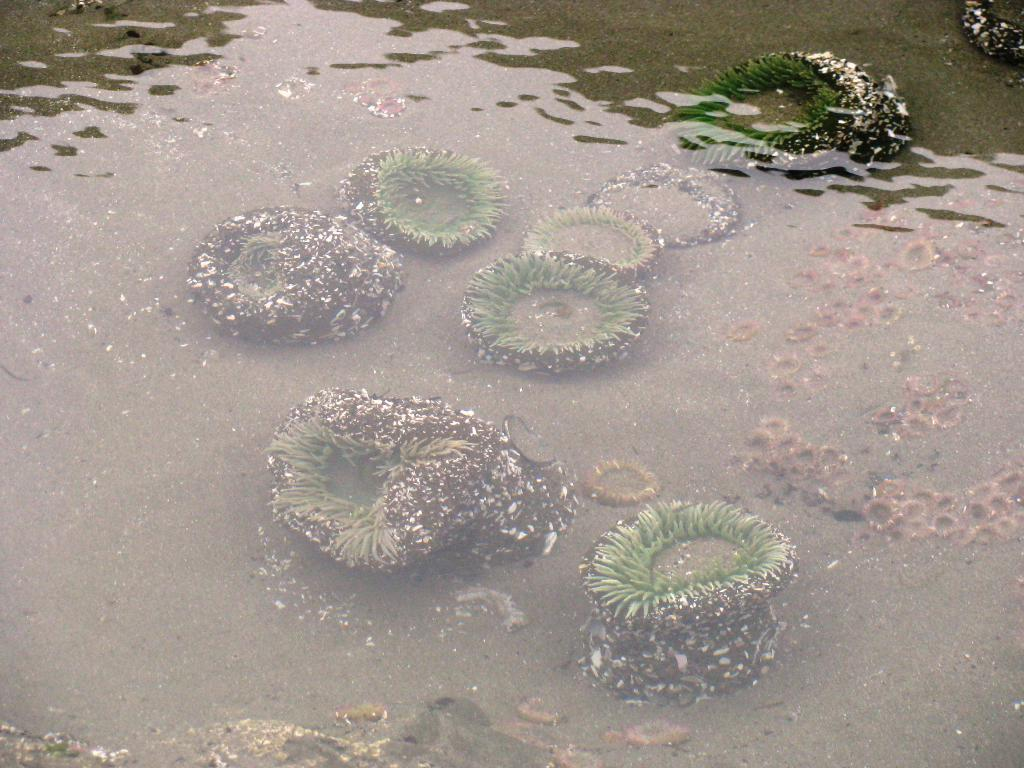What is the primary element visible in the image? Water is visible in the image. What type of vegetation can be seen in the water? There are underwater plants in the image. What type of door can be seen in the image? There is no door present in the image; it features water and underwater plants. What kind of pipe is visible in the image? There is no pipe present in the image; it features water and underwater plants. 